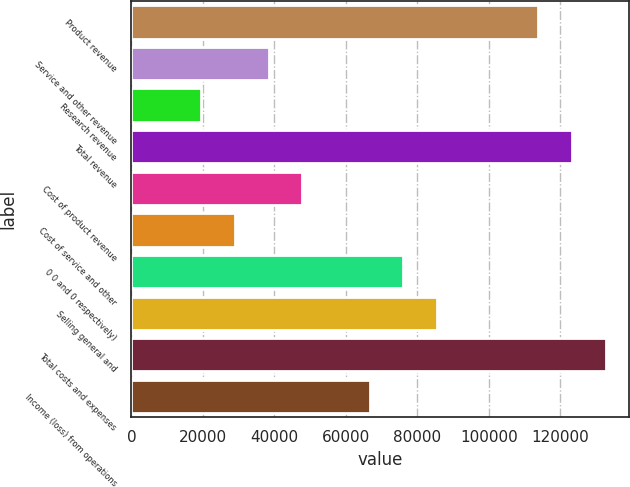Convert chart to OTSL. <chart><loc_0><loc_0><loc_500><loc_500><bar_chart><fcel>Product revenue<fcel>Service and other revenue<fcel>Research revenue<fcel>Total revenue<fcel>Cost of product revenue<fcel>Cost of service and other<fcel>0 0 and 0 respectively)<fcel>Selling general and<fcel>Total costs and expenses<fcel>Income (loss) from operations<nl><fcel>113804<fcel>38380<fcel>19524<fcel>123232<fcel>47808<fcel>28952<fcel>76092<fcel>85520<fcel>132660<fcel>66664<nl></chart> 